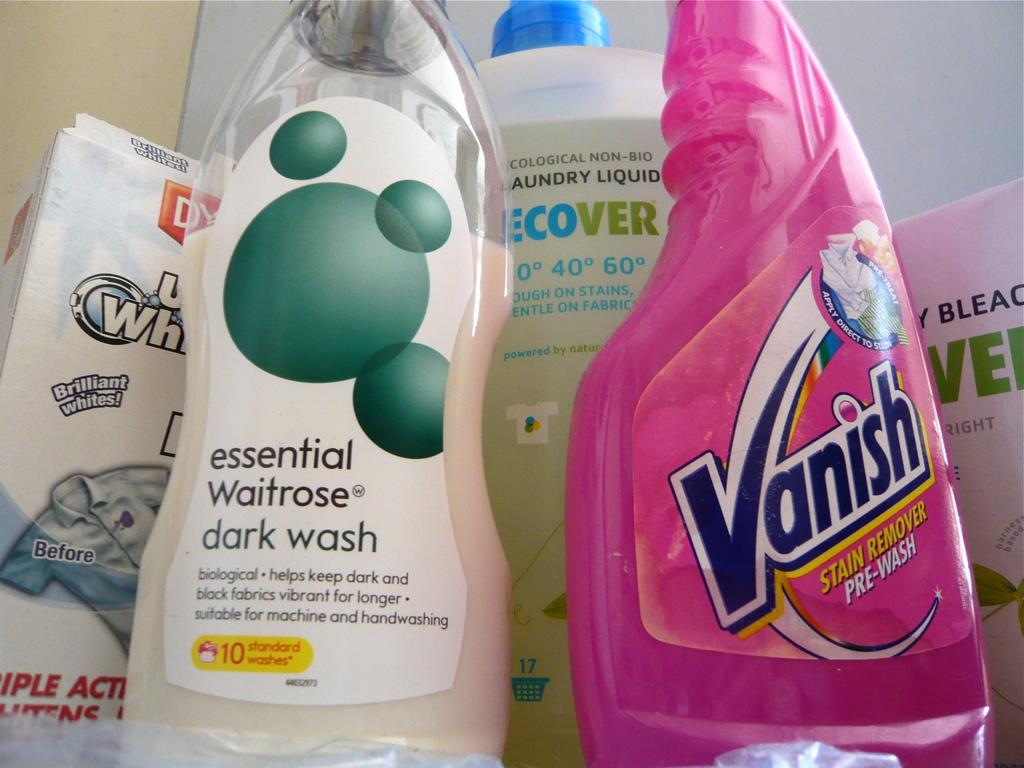<image>
Summarize the visual content of the image. A bottle of essential Waitrose dark wash detergent next to Vanish stain remover. 